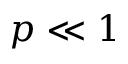<formula> <loc_0><loc_0><loc_500><loc_500>p \ll 1</formula> 